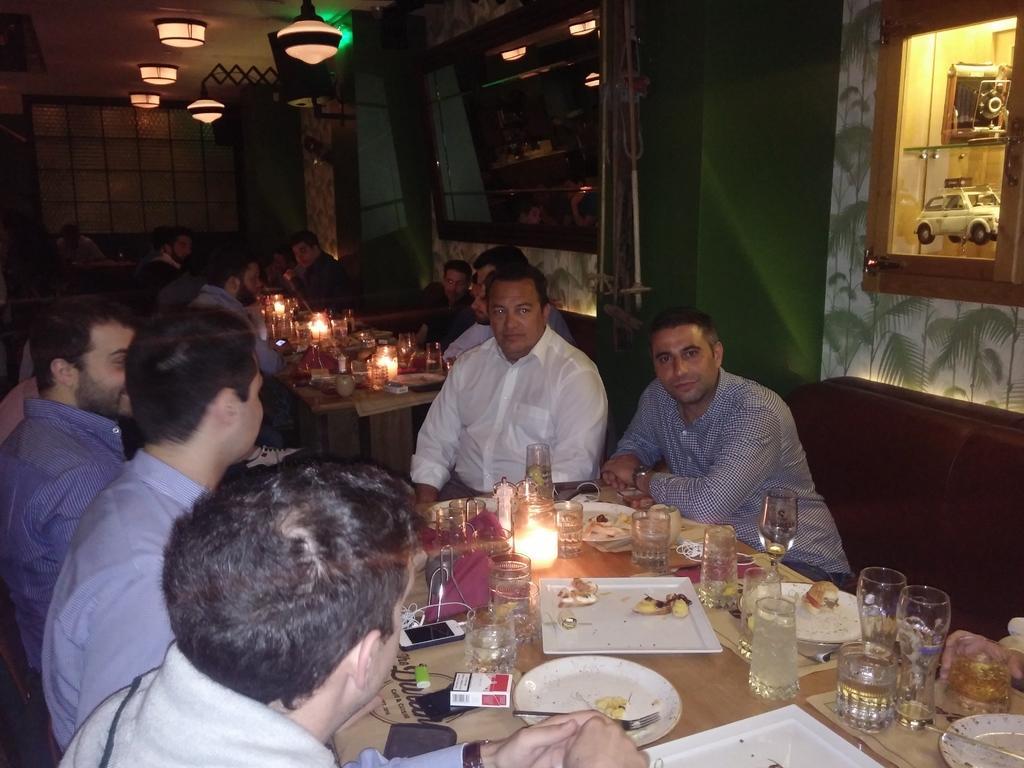Describe this image in one or two sentences. In this image we can see a few people sitting on the seats, there are tables, on the tables, there are candles, glasses, plates, forks, there is a cigarette box and a cell, phone, also we can see some other objects, there are lights, there are some toys in the cupboard, also we can see the wall. 